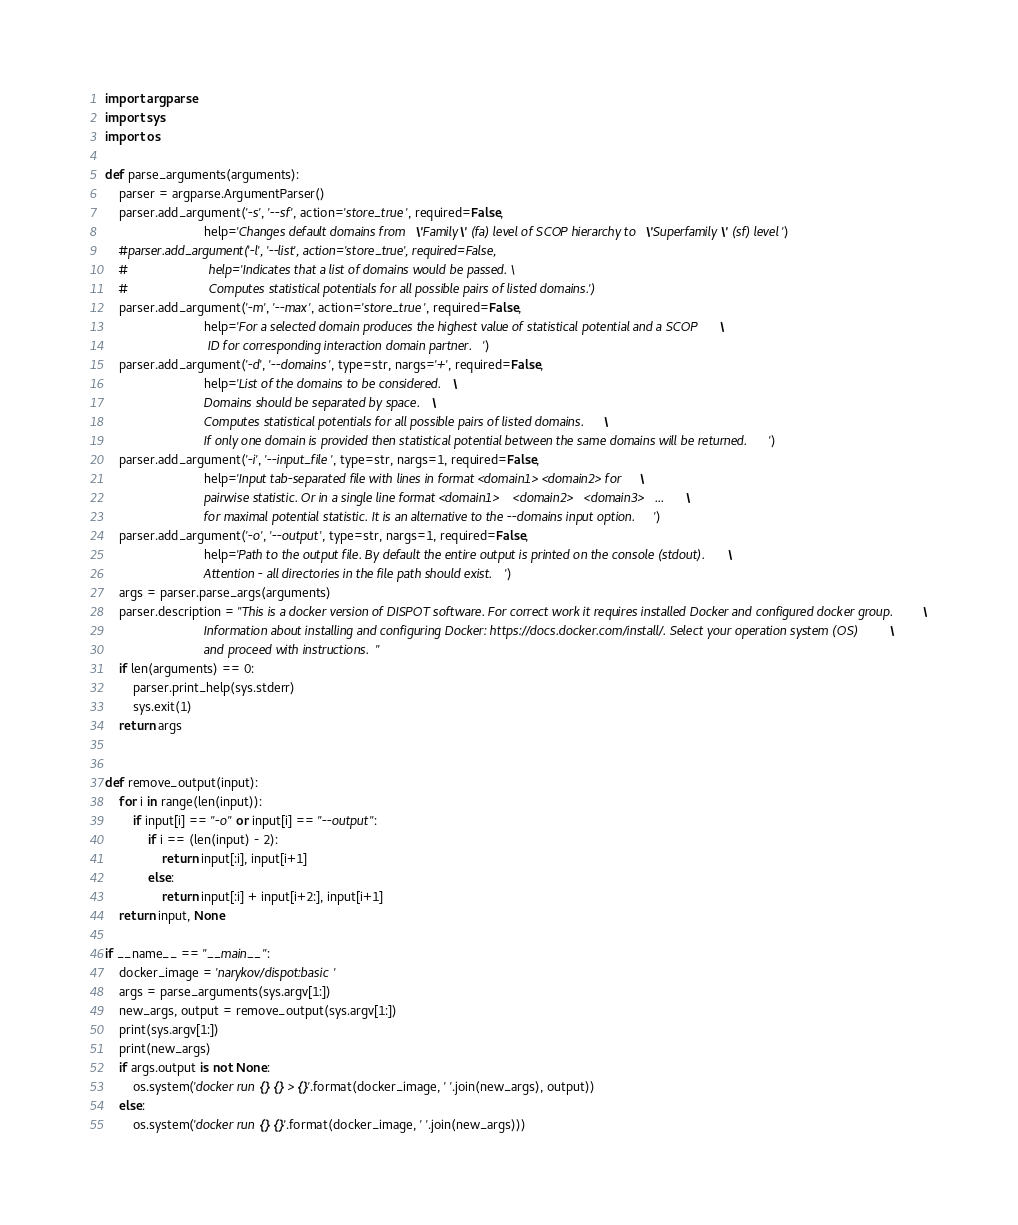<code> <loc_0><loc_0><loc_500><loc_500><_Python_>import argparse
import sys
import os

def parse_arguments(arguments):
	parser = argparse.ArgumentParser()
	parser.add_argument('-s', '--sf', action='store_true', required=False,
							help='Changes default domains from \'Family\' (fa) level of SCOP hierarchy to \'Superfamily\' (sf) level')
	#parser.add_argument('-l', '--list', action='store_true', required=False, 
	#						help='Indicates that a list of domains would be passed. \
	#						Computes statistical potentials for all possible pairs of listed domains.')
	parser.add_argument('-m', '--max', action='store_true', required=False,
							help='For a selected domain produces the highest value of statistical potential and a SCOP \
							 ID for corresponding interaction domain partner.')
	parser.add_argument('-d', '--domains', type=str, nargs='+', required=False,
							help='List of the domains to be considered. \
							Domains should be separated by space. \
							Computes statistical potentials for all possible pairs of listed domains. \
							If only one domain is provided then statistical potential between the same domains will be returned.')
	parser.add_argument('-i', '--input_file', type=str, nargs=1, required=False,
							help='Input tab-separated file with lines in format <domain1>	<domain2> for \
							pairwise statistic. Or in a single line format <domain1>	<domain2>	<domain3> 	... \
							for maximal potential statistic. It is an alternative to the --domains input option.')
	parser.add_argument('-o', '--output', type=str, nargs=1, required=False,
							help='Path to the output file. By default the entire output is printed on the console (stdout). \
							Attention - all directories in the file path should exist.')
	args = parser.parse_args(arguments)
	parser.description = "This is a docker version of DISPOT software. For correct work it requires installed Docker and configured docker group. \
							Information about installing and configuring Docker: https://docs.docker.com/install/. Select your operation system (OS) \
							and proceed with instructions."
	if len(arguments) == 0:
		parser.print_help(sys.stderr)
		sys.exit(1)
	return args


def remove_output(input):
	for i in range(len(input)):
		if input[i] == "-o" or input[i] == "--output":
			if i == (len(input) - 2):
				return input[:i], input[i+1]
			else:
				return input[:i] + input[i+2:], input[i+1]
	return input, None

if __name__ == "__main__":
	docker_image = 'narykov/dispot:basic'
	args = parse_arguments(sys.argv[1:])
	new_args, output = remove_output(sys.argv[1:])
	print(sys.argv[1:])
	print(new_args)
	if args.output is not None:
		os.system('docker run {} {} > {}'.format(docker_image, ' '.join(new_args), output))
	else:
		os.system('docker run {} {}'.format(docker_image, ' '.join(new_args)))</code> 